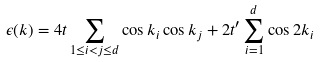<formula> <loc_0><loc_0><loc_500><loc_500>\epsilon ( { k } ) = 4 t \sum _ { 1 \leq i < j \leq d } \cos { k _ { i } } \cos { k _ { j } } + 2 t ^ { \prime } \sum _ { i = 1 } ^ { d } \cos { 2 k _ { i } }</formula> 